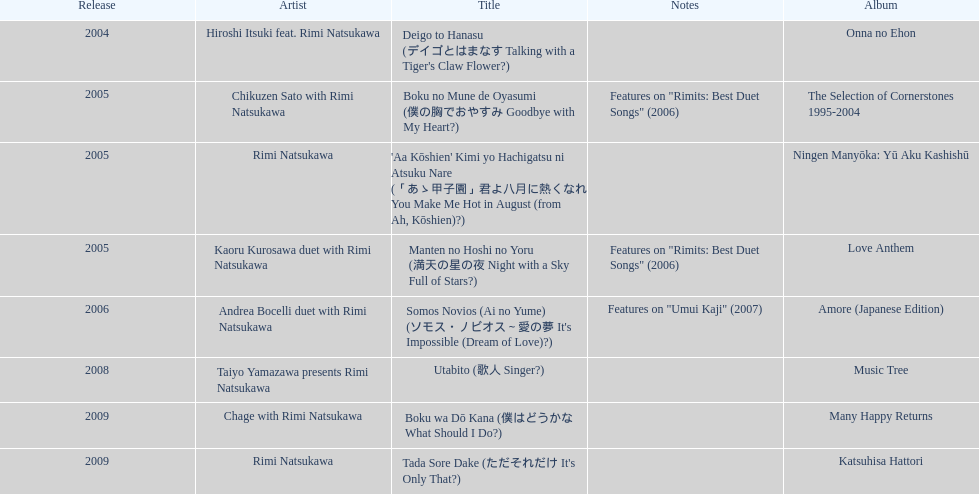In which year were the most titles launched? 2005. 